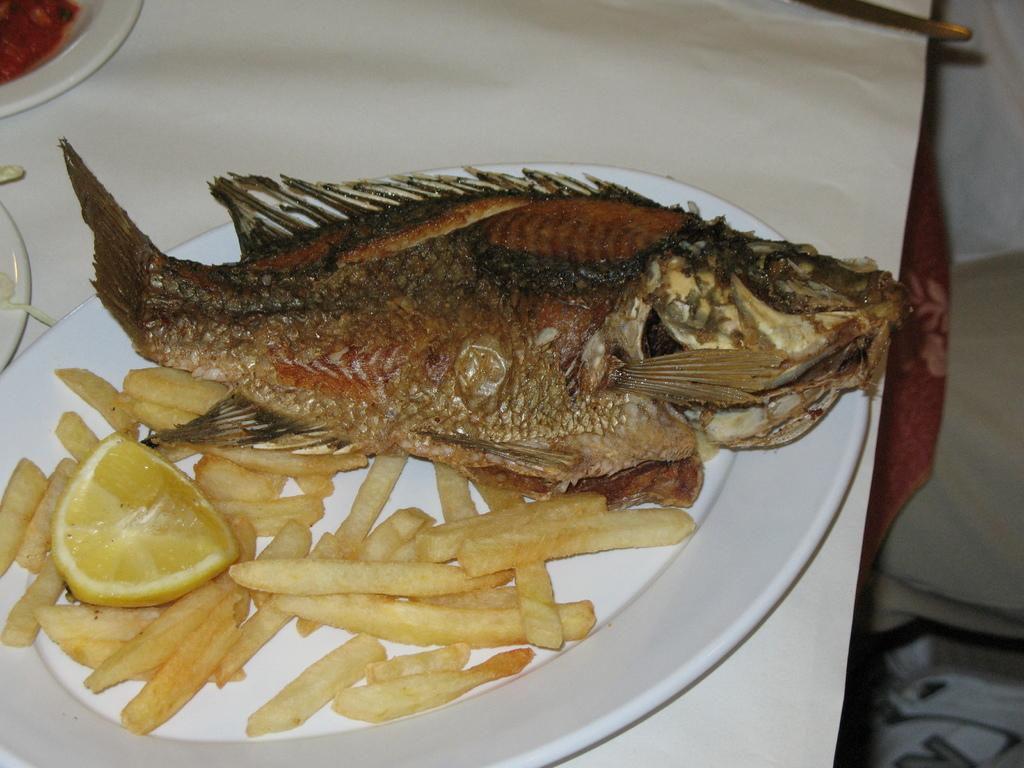What type of food is the main subject of the image? There is a fried fish in the image. What other food items are present in the image? There are french fries and a piece of lemon in the image. How are the food items arranged in the image? The food items are placed on a plate, and the plate is placed on a table. Are there any other plates visible in the image? Yes, there are additional plates beside the main plate. What type of polish is being applied to the fish in the image? There is no polish being applied to the fish in the image; it is a cooked dish. What is the reaction of the lemon to the presence of the fried fish in the image? The lemon is an inanimate object and does not have a reaction to the presence of the fried fish in the image. 